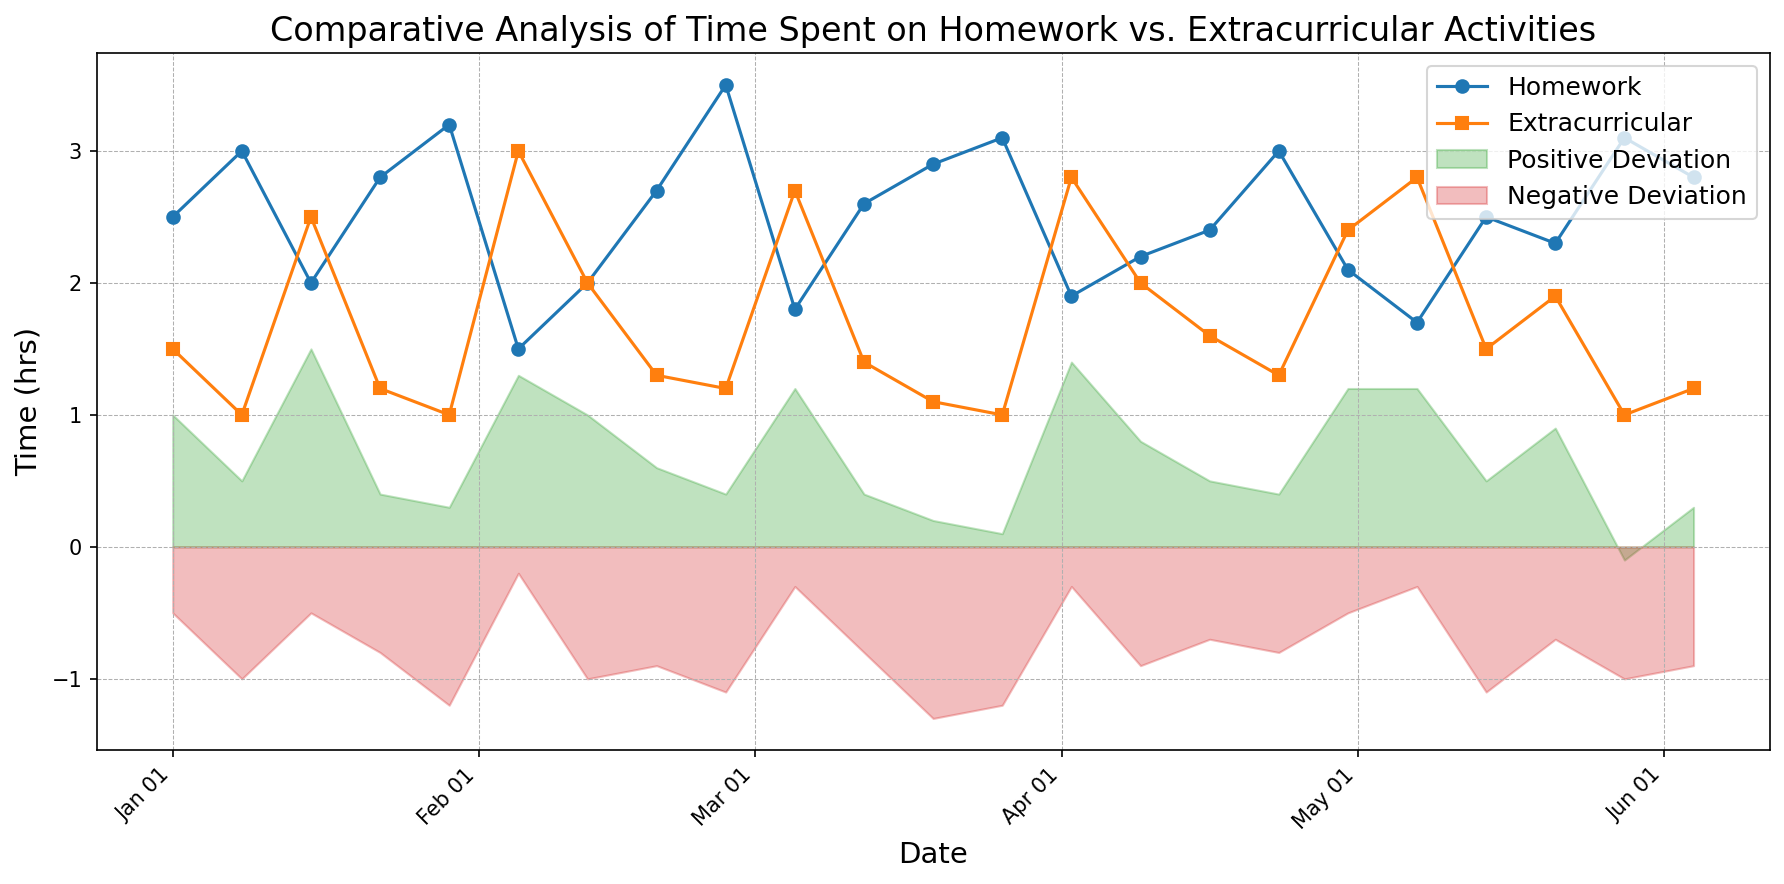Which time period had the highest time spent on homework? By observing the plot, the highest peak on the 'Homework' line indicates the time period. Specifically, the peak around early March shows the highest value.
Answer: Early March Which date shows a greater amount of time spent on Extracurricular Activities compared to Homework? Looking at both lines for Homework and Extracurricular Activities, find when the orange line (Extracurricular) is above the blue line (Homework).
Answer: 2023-02-05 When was the Positive Deviation highest? Identify the peak in the green shaded area, this represents the highest value of Positive Deviation on the plot. Examine the dates closely below that peak.
Answer: 2023-01-15 What is the time difference in hours between Homework and Extracurricular Activities on 2023-03-05? Check the data for 2023-03-05 and subtract the value for Extracurricular Activities from the value for Homework. Specifically, 1.8 (Homework) - 2.7 (Extracurricular Activities).
Answer: -0.9 hours Which period shows no Negative Deviation? The red shaded area indicating Negative Deviation should be zero, find the time on the x-axis where there are no red areas. After carefully examining the plot, there isn’t a time where Negative Deviation is entirely absent, but minimal values can be expected. Thus, it is rare.
Answer: None What's the average time spent on homework over the dates shown? Sum all values for Homework and divide by the number of dates. Specifically, (2.5 + 3.0 + 2.0 + 2.8 + 3.2 + 1.5 + 2.0 + 2.7 + 3.5 + 1.8 + 2.6 + 2.9 + 3.1 + 1.9 + 2.2 + 2.4 + 3.0 + 2.1 + 1.7 + 2.5 + 2.3 + 3.1 + 2.8) / 23 = 2.57 hours (approx).
Answer: 2.57 hours How many dates show Homework time spent greater than or equal to 3 hours? Count the peaks of the blue line where values are greater than or equal to 3. The periods are: 2023-01-08, 2023-01-29, 2023-02-26, 2023-03-19, 2023-03-26, 2023-05-28. Count these instances.
Answer: 6 dates When did both Homework and Positive Deviation have peaks on the same date? Look at the plot where both the blue line and the green shaded area show a peak on the same date. This can be seen around the mid-January period.
Answer: 2023-01-15 On which date did Homework time increase while Extracurricular Activities time decreased compared to the previous date? To observe the trend, find a date where the blue line increases, and the orange line decreases in subsequent intervals. Specifically moving from early January to early February for better correlation. One such date is 2023-01-08.
Answer: 2023-01-08 